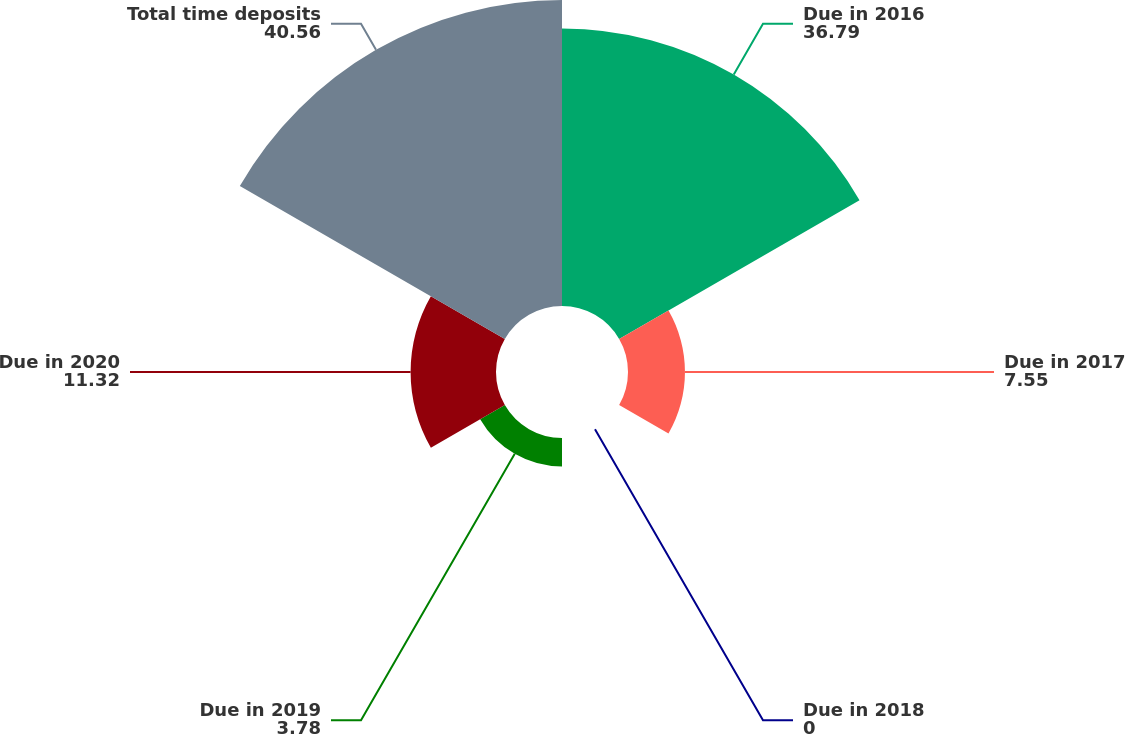<chart> <loc_0><loc_0><loc_500><loc_500><pie_chart><fcel>Due in 2016<fcel>Due in 2017<fcel>Due in 2018<fcel>Due in 2019<fcel>Due in 2020<fcel>Total time deposits<nl><fcel>36.79%<fcel>7.55%<fcel>0.0%<fcel>3.78%<fcel>11.32%<fcel>40.56%<nl></chart> 